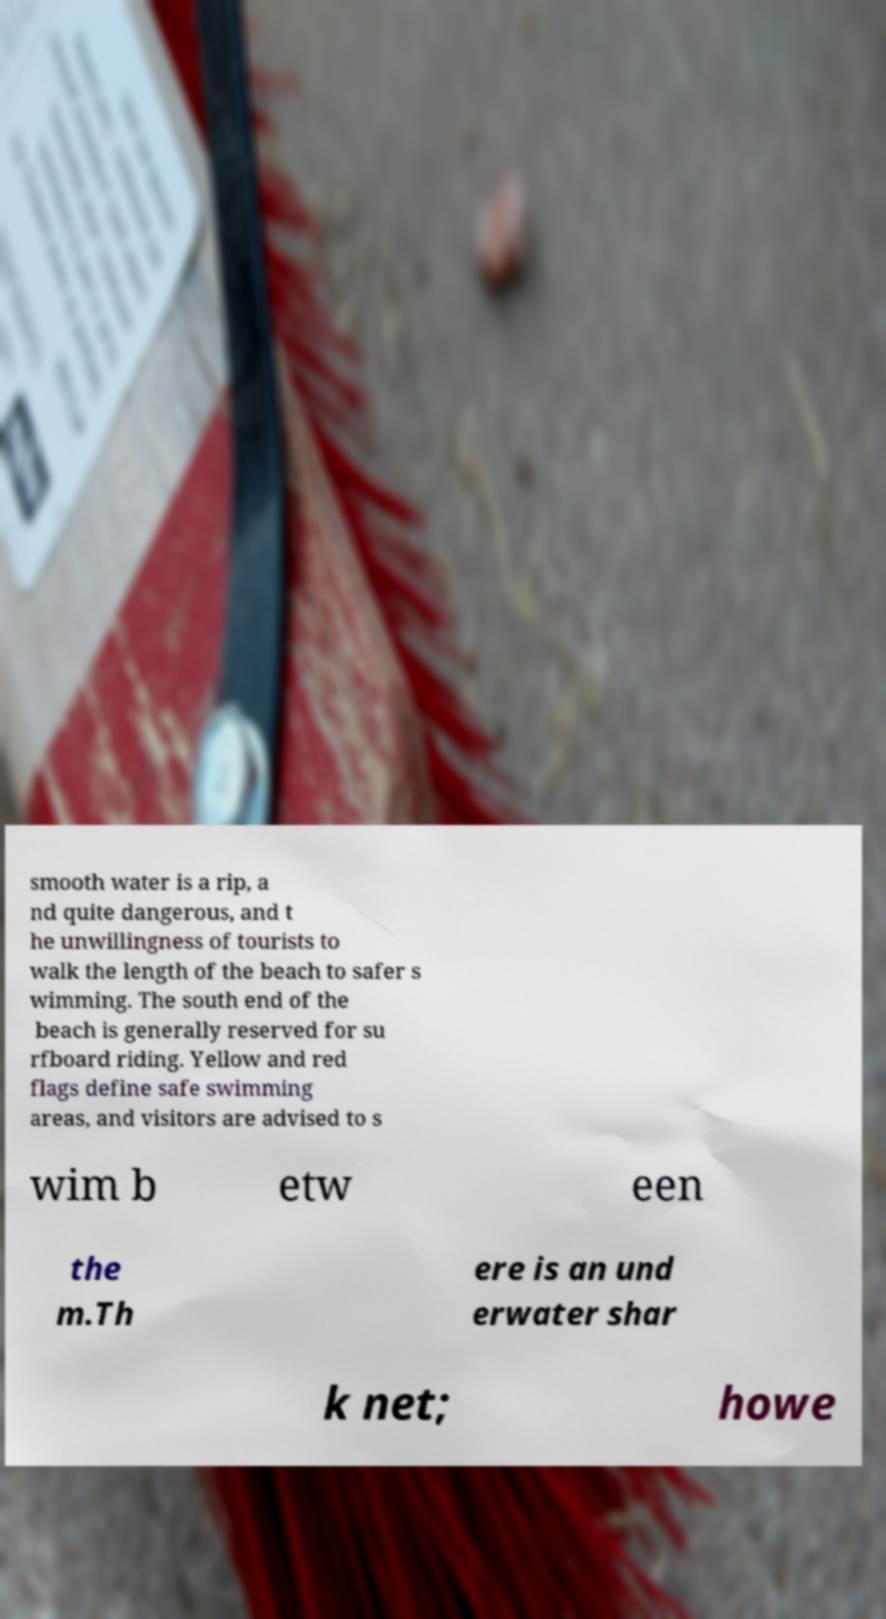Please identify and transcribe the text found in this image. smooth water is a rip, a nd quite dangerous, and t he unwillingness of tourists to walk the length of the beach to safer s wimming. The south end of the beach is generally reserved for su rfboard riding. Yellow and red flags define safe swimming areas, and visitors are advised to s wim b etw een the m.Th ere is an und erwater shar k net; howe 